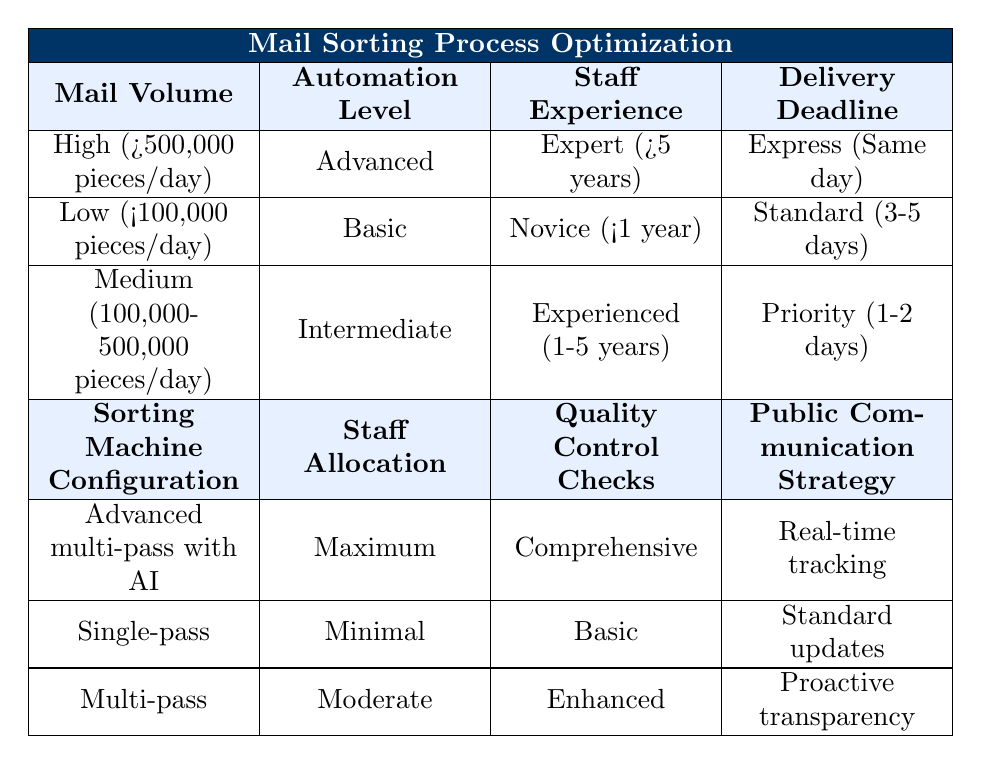What sorting machine configuration is used for high mail volume? From the table, the sorting machine configuration for high mail volume is specified as "Advanced multi-pass with AI." This is found in the first row under the corresponding conditions.
Answer: Advanced multi-pass with AI What is the staff allocation for low mail volume? The staff allocation for low mail volume can be found in the second row of the table, which states that it is "Minimal."
Answer: Minimal Is the quality control check for medium mail volume enhanced? Looking at the quality control checks for medium mail volume in the third row, it shows "Enhanced," confirming the check level for this category.
Answer: Yes How many different options are there for the public communication strategy in the context of staff experience? The table has three rows with different staff experience levels, and each has a corresponding public communication strategy option. As there are three rows, there are three options available.
Answer: 3 If we have a medium mail volume with an intermediate automation level, what is the staff experience required? Referring to the conditions for medium mail volume and intermediate automation level, the corresponding staff experience level is "Experienced (1-5 years)," as seen in the third row.
Answer: Experienced (1-5 years) For an expert staff experience, what is the delivery deadline option available? The table indicates that for the "Expert (>5 years)" staff experience under high mail volume, the delivery deadline is "Express (Same day)." This can be found in the first row.
Answer: Express (Same day) Is there comprehensive quality control for low mail volume? According to the second row from the table, the quality control checks for low mail volume are "Basic," not comprehensive, so this statement is false.
Answer: No What is the average staff allocation between minimal and maximum allocations? The staff allocation options are "Minimal," "Moderate," and "Maximum." To determine the average, we assign numerical values: Minimal = 1, Moderate = 2, Maximum = 3. The average is (1 + 2 + 3) / 3 = 2, which corresponds to "Moderate."
Answer: Moderate 